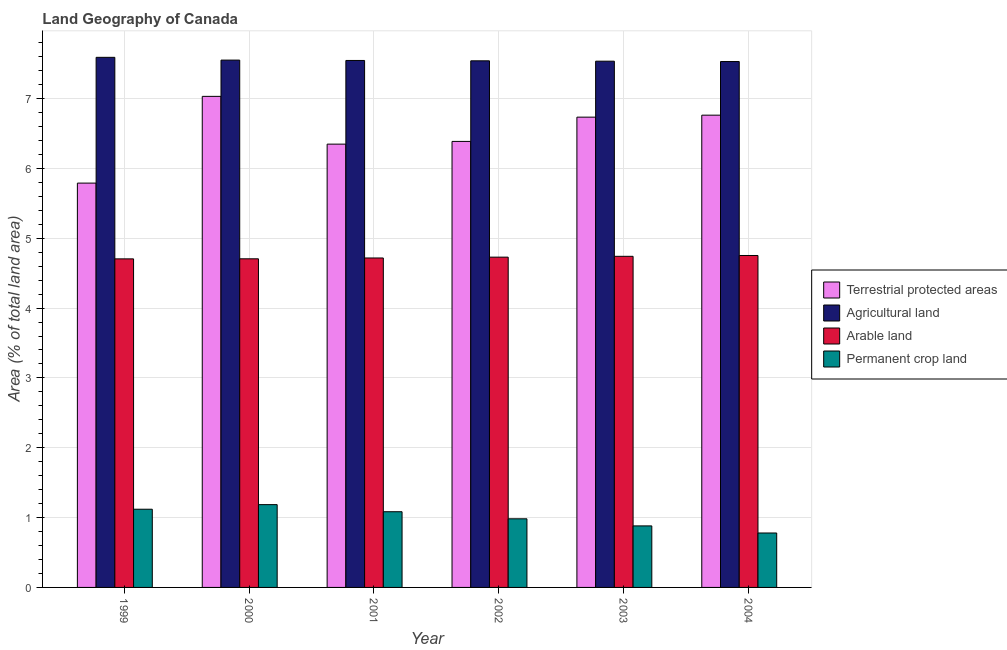How many groups of bars are there?
Your response must be concise. 6. Are the number of bars on each tick of the X-axis equal?
Your response must be concise. Yes. What is the percentage of area under agricultural land in 2000?
Keep it short and to the point. 7.55. Across all years, what is the maximum percentage of area under agricultural land?
Make the answer very short. 7.59. Across all years, what is the minimum percentage of area under permanent crop land?
Give a very brief answer. 0.78. In which year was the percentage of area under agricultural land maximum?
Your response must be concise. 1999. In which year was the percentage of area under arable land minimum?
Provide a short and direct response. 1999. What is the total percentage of area under agricultural land in the graph?
Give a very brief answer. 45.29. What is the difference between the percentage of area under permanent crop land in 1999 and that in 2004?
Your answer should be compact. 0.34. What is the difference between the percentage of area under permanent crop land in 2004 and the percentage of area under arable land in 2000?
Offer a terse response. -0.41. What is the average percentage of land under terrestrial protection per year?
Ensure brevity in your answer.  6.51. In the year 2001, what is the difference between the percentage of land under terrestrial protection and percentage of area under arable land?
Offer a terse response. 0. In how many years, is the percentage of land under terrestrial protection greater than 4.6 %?
Make the answer very short. 6. What is the ratio of the percentage of area under permanent crop land in 2002 to that in 2004?
Provide a short and direct response. 1.26. Is the percentage of area under permanent crop land in 2002 less than that in 2004?
Ensure brevity in your answer.  No. Is the difference between the percentage of land under terrestrial protection in 2003 and 2004 greater than the difference between the percentage of area under agricultural land in 2003 and 2004?
Your answer should be very brief. No. What is the difference between the highest and the second highest percentage of area under permanent crop land?
Keep it short and to the point. 0.07. What is the difference between the highest and the lowest percentage of land under terrestrial protection?
Provide a short and direct response. 1.24. In how many years, is the percentage of land under terrestrial protection greater than the average percentage of land under terrestrial protection taken over all years?
Ensure brevity in your answer.  3. Is the sum of the percentage of land under terrestrial protection in 2000 and 2002 greater than the maximum percentage of area under permanent crop land across all years?
Give a very brief answer. Yes. What does the 1st bar from the left in 2004 represents?
Your answer should be very brief. Terrestrial protected areas. What does the 3rd bar from the right in 2003 represents?
Give a very brief answer. Agricultural land. How many bars are there?
Ensure brevity in your answer.  24. Does the graph contain any zero values?
Offer a terse response. No. Does the graph contain grids?
Keep it short and to the point. Yes. Where does the legend appear in the graph?
Offer a very short reply. Center right. How are the legend labels stacked?
Provide a short and direct response. Vertical. What is the title of the graph?
Keep it short and to the point. Land Geography of Canada. Does "Luxembourg" appear as one of the legend labels in the graph?
Offer a very short reply. No. What is the label or title of the Y-axis?
Ensure brevity in your answer.  Area (% of total land area). What is the Area (% of total land area) of Terrestrial protected areas in 1999?
Offer a very short reply. 5.79. What is the Area (% of total land area) in Agricultural land in 1999?
Offer a very short reply. 7.59. What is the Area (% of total land area) of Arable land in 1999?
Offer a very short reply. 4.7. What is the Area (% of total land area) of Permanent crop land in 1999?
Your answer should be compact. 1.12. What is the Area (% of total land area) of Terrestrial protected areas in 2000?
Provide a succinct answer. 7.03. What is the Area (% of total land area) in Agricultural land in 2000?
Provide a succinct answer. 7.55. What is the Area (% of total land area) in Arable land in 2000?
Your answer should be compact. 4.71. What is the Area (% of total land area) in Permanent crop land in 2000?
Your answer should be very brief. 1.19. What is the Area (% of total land area) of Terrestrial protected areas in 2001?
Offer a very short reply. 6.35. What is the Area (% of total land area) in Agricultural land in 2001?
Provide a short and direct response. 7.55. What is the Area (% of total land area) of Arable land in 2001?
Your answer should be compact. 4.72. What is the Area (% of total land area) of Permanent crop land in 2001?
Provide a succinct answer. 1.08. What is the Area (% of total land area) of Terrestrial protected areas in 2002?
Provide a succinct answer. 6.39. What is the Area (% of total land area) in Agricultural land in 2002?
Your response must be concise. 7.54. What is the Area (% of total land area) in Arable land in 2002?
Your answer should be very brief. 4.73. What is the Area (% of total land area) of Permanent crop land in 2002?
Provide a short and direct response. 0.98. What is the Area (% of total land area) in Terrestrial protected areas in 2003?
Your answer should be compact. 6.73. What is the Area (% of total land area) in Agricultural land in 2003?
Offer a very short reply. 7.53. What is the Area (% of total land area) of Arable land in 2003?
Your response must be concise. 4.74. What is the Area (% of total land area) of Permanent crop land in 2003?
Keep it short and to the point. 0.88. What is the Area (% of total land area) of Terrestrial protected areas in 2004?
Your answer should be very brief. 6.76. What is the Area (% of total land area) in Agricultural land in 2004?
Provide a succinct answer. 7.53. What is the Area (% of total land area) in Arable land in 2004?
Provide a short and direct response. 4.75. What is the Area (% of total land area) of Permanent crop land in 2004?
Ensure brevity in your answer.  0.78. Across all years, what is the maximum Area (% of total land area) of Terrestrial protected areas?
Provide a succinct answer. 7.03. Across all years, what is the maximum Area (% of total land area) of Agricultural land?
Your answer should be very brief. 7.59. Across all years, what is the maximum Area (% of total land area) of Arable land?
Offer a terse response. 4.75. Across all years, what is the maximum Area (% of total land area) in Permanent crop land?
Offer a terse response. 1.19. Across all years, what is the minimum Area (% of total land area) in Terrestrial protected areas?
Your answer should be very brief. 5.79. Across all years, what is the minimum Area (% of total land area) in Agricultural land?
Offer a very short reply. 7.53. Across all years, what is the minimum Area (% of total land area) in Arable land?
Make the answer very short. 4.7. Across all years, what is the minimum Area (% of total land area) in Permanent crop land?
Ensure brevity in your answer.  0.78. What is the total Area (% of total land area) of Terrestrial protected areas in the graph?
Make the answer very short. 39.05. What is the total Area (% of total land area) of Agricultural land in the graph?
Provide a short and direct response. 45.29. What is the total Area (% of total land area) in Arable land in the graph?
Give a very brief answer. 28.35. What is the total Area (% of total land area) of Permanent crop land in the graph?
Keep it short and to the point. 6.03. What is the difference between the Area (% of total land area) of Terrestrial protected areas in 1999 and that in 2000?
Ensure brevity in your answer.  -1.24. What is the difference between the Area (% of total land area) in Agricultural land in 1999 and that in 2000?
Give a very brief answer. 0.04. What is the difference between the Area (% of total land area) of Arable land in 1999 and that in 2000?
Offer a terse response. -0. What is the difference between the Area (% of total land area) of Permanent crop land in 1999 and that in 2000?
Make the answer very short. -0.07. What is the difference between the Area (% of total land area) in Terrestrial protected areas in 1999 and that in 2001?
Your answer should be compact. -0.56. What is the difference between the Area (% of total land area) in Agricultural land in 1999 and that in 2001?
Offer a very short reply. 0.04. What is the difference between the Area (% of total land area) of Arable land in 1999 and that in 2001?
Make the answer very short. -0.01. What is the difference between the Area (% of total land area) of Permanent crop land in 1999 and that in 2001?
Your answer should be compact. 0.04. What is the difference between the Area (% of total land area) of Terrestrial protected areas in 1999 and that in 2002?
Make the answer very short. -0.6. What is the difference between the Area (% of total land area) of Arable land in 1999 and that in 2002?
Your response must be concise. -0.02. What is the difference between the Area (% of total land area) in Permanent crop land in 1999 and that in 2002?
Offer a terse response. 0.14. What is the difference between the Area (% of total land area) in Terrestrial protected areas in 1999 and that in 2003?
Ensure brevity in your answer.  -0.94. What is the difference between the Area (% of total land area) in Agricultural land in 1999 and that in 2003?
Offer a terse response. 0.06. What is the difference between the Area (% of total land area) of Arable land in 1999 and that in 2003?
Give a very brief answer. -0.04. What is the difference between the Area (% of total land area) of Permanent crop land in 1999 and that in 2003?
Provide a short and direct response. 0.24. What is the difference between the Area (% of total land area) in Terrestrial protected areas in 1999 and that in 2004?
Ensure brevity in your answer.  -0.97. What is the difference between the Area (% of total land area) of Agricultural land in 1999 and that in 2004?
Offer a terse response. 0.06. What is the difference between the Area (% of total land area) in Arable land in 1999 and that in 2004?
Offer a terse response. -0.05. What is the difference between the Area (% of total land area) in Permanent crop land in 1999 and that in 2004?
Give a very brief answer. 0.34. What is the difference between the Area (% of total land area) of Terrestrial protected areas in 2000 and that in 2001?
Give a very brief answer. 0.68. What is the difference between the Area (% of total land area) in Agricultural land in 2000 and that in 2001?
Offer a very short reply. 0.01. What is the difference between the Area (% of total land area) of Arable land in 2000 and that in 2001?
Keep it short and to the point. -0.01. What is the difference between the Area (% of total land area) in Permanent crop land in 2000 and that in 2001?
Provide a short and direct response. 0.1. What is the difference between the Area (% of total land area) in Terrestrial protected areas in 2000 and that in 2002?
Provide a short and direct response. 0.65. What is the difference between the Area (% of total land area) in Agricultural land in 2000 and that in 2002?
Make the answer very short. 0.01. What is the difference between the Area (% of total land area) of Arable land in 2000 and that in 2002?
Your answer should be very brief. -0.02. What is the difference between the Area (% of total land area) of Permanent crop land in 2000 and that in 2002?
Provide a short and direct response. 0.2. What is the difference between the Area (% of total land area) of Terrestrial protected areas in 2000 and that in 2003?
Keep it short and to the point. 0.3. What is the difference between the Area (% of total land area) of Agricultural land in 2000 and that in 2003?
Offer a terse response. 0.02. What is the difference between the Area (% of total land area) in Arable land in 2000 and that in 2003?
Offer a very short reply. -0.04. What is the difference between the Area (% of total land area) in Permanent crop land in 2000 and that in 2003?
Give a very brief answer. 0.3. What is the difference between the Area (% of total land area) in Terrestrial protected areas in 2000 and that in 2004?
Offer a terse response. 0.27. What is the difference between the Area (% of total land area) of Agricultural land in 2000 and that in 2004?
Keep it short and to the point. 0.02. What is the difference between the Area (% of total land area) in Arable land in 2000 and that in 2004?
Your answer should be compact. -0.05. What is the difference between the Area (% of total land area) of Permanent crop land in 2000 and that in 2004?
Make the answer very short. 0.41. What is the difference between the Area (% of total land area) of Terrestrial protected areas in 2001 and that in 2002?
Provide a short and direct response. -0.04. What is the difference between the Area (% of total land area) of Agricultural land in 2001 and that in 2002?
Give a very brief answer. 0.01. What is the difference between the Area (% of total land area) in Arable land in 2001 and that in 2002?
Your answer should be compact. -0.01. What is the difference between the Area (% of total land area) in Permanent crop land in 2001 and that in 2002?
Your response must be concise. 0.1. What is the difference between the Area (% of total land area) of Terrestrial protected areas in 2001 and that in 2003?
Ensure brevity in your answer.  -0.39. What is the difference between the Area (% of total land area) of Agricultural land in 2001 and that in 2003?
Give a very brief answer. 0.01. What is the difference between the Area (% of total land area) in Arable land in 2001 and that in 2003?
Make the answer very short. -0.02. What is the difference between the Area (% of total land area) in Permanent crop land in 2001 and that in 2003?
Offer a terse response. 0.2. What is the difference between the Area (% of total land area) in Terrestrial protected areas in 2001 and that in 2004?
Ensure brevity in your answer.  -0.41. What is the difference between the Area (% of total land area) of Agricultural land in 2001 and that in 2004?
Provide a succinct answer. 0.02. What is the difference between the Area (% of total land area) in Arable land in 2001 and that in 2004?
Give a very brief answer. -0.04. What is the difference between the Area (% of total land area) of Permanent crop land in 2001 and that in 2004?
Your response must be concise. 0.3. What is the difference between the Area (% of total land area) of Terrestrial protected areas in 2002 and that in 2003?
Ensure brevity in your answer.  -0.35. What is the difference between the Area (% of total land area) in Agricultural land in 2002 and that in 2003?
Make the answer very short. 0.01. What is the difference between the Area (% of total land area) of Arable land in 2002 and that in 2003?
Ensure brevity in your answer.  -0.01. What is the difference between the Area (% of total land area) of Permanent crop land in 2002 and that in 2003?
Offer a terse response. 0.1. What is the difference between the Area (% of total land area) in Terrestrial protected areas in 2002 and that in 2004?
Make the answer very short. -0.38. What is the difference between the Area (% of total land area) of Agricultural land in 2002 and that in 2004?
Ensure brevity in your answer.  0.01. What is the difference between the Area (% of total land area) of Arable land in 2002 and that in 2004?
Give a very brief answer. -0.02. What is the difference between the Area (% of total land area) of Permanent crop land in 2002 and that in 2004?
Provide a short and direct response. 0.2. What is the difference between the Area (% of total land area) in Terrestrial protected areas in 2003 and that in 2004?
Ensure brevity in your answer.  -0.03. What is the difference between the Area (% of total land area) of Agricultural land in 2003 and that in 2004?
Your answer should be very brief. 0.01. What is the difference between the Area (% of total land area) in Arable land in 2003 and that in 2004?
Provide a succinct answer. -0.01. What is the difference between the Area (% of total land area) of Permanent crop land in 2003 and that in 2004?
Your answer should be compact. 0.1. What is the difference between the Area (% of total land area) in Terrestrial protected areas in 1999 and the Area (% of total land area) in Agricultural land in 2000?
Provide a succinct answer. -1.76. What is the difference between the Area (% of total land area) in Terrestrial protected areas in 1999 and the Area (% of total land area) in Arable land in 2000?
Ensure brevity in your answer.  1.08. What is the difference between the Area (% of total land area) in Terrestrial protected areas in 1999 and the Area (% of total land area) in Permanent crop land in 2000?
Provide a succinct answer. 4.6. What is the difference between the Area (% of total land area) of Agricultural land in 1999 and the Area (% of total land area) of Arable land in 2000?
Offer a terse response. 2.88. What is the difference between the Area (% of total land area) of Agricultural land in 1999 and the Area (% of total land area) of Permanent crop land in 2000?
Your response must be concise. 6.4. What is the difference between the Area (% of total land area) of Arable land in 1999 and the Area (% of total land area) of Permanent crop land in 2000?
Give a very brief answer. 3.52. What is the difference between the Area (% of total land area) of Terrestrial protected areas in 1999 and the Area (% of total land area) of Agricultural land in 2001?
Keep it short and to the point. -1.76. What is the difference between the Area (% of total land area) in Terrestrial protected areas in 1999 and the Area (% of total land area) in Arable land in 2001?
Offer a very short reply. 1.07. What is the difference between the Area (% of total land area) in Terrestrial protected areas in 1999 and the Area (% of total land area) in Permanent crop land in 2001?
Ensure brevity in your answer.  4.71. What is the difference between the Area (% of total land area) of Agricultural land in 1999 and the Area (% of total land area) of Arable land in 2001?
Your answer should be very brief. 2.87. What is the difference between the Area (% of total land area) of Agricultural land in 1999 and the Area (% of total land area) of Permanent crop land in 2001?
Keep it short and to the point. 6.51. What is the difference between the Area (% of total land area) of Arable land in 1999 and the Area (% of total land area) of Permanent crop land in 2001?
Your answer should be very brief. 3.62. What is the difference between the Area (% of total land area) in Terrestrial protected areas in 1999 and the Area (% of total land area) in Agricultural land in 2002?
Provide a short and direct response. -1.75. What is the difference between the Area (% of total land area) of Terrestrial protected areas in 1999 and the Area (% of total land area) of Arable land in 2002?
Your answer should be compact. 1.06. What is the difference between the Area (% of total land area) of Terrestrial protected areas in 1999 and the Area (% of total land area) of Permanent crop land in 2002?
Provide a succinct answer. 4.81. What is the difference between the Area (% of total land area) of Agricultural land in 1999 and the Area (% of total land area) of Arable land in 2002?
Your answer should be very brief. 2.86. What is the difference between the Area (% of total land area) in Agricultural land in 1999 and the Area (% of total land area) in Permanent crop land in 2002?
Your answer should be very brief. 6.61. What is the difference between the Area (% of total land area) in Arable land in 1999 and the Area (% of total land area) in Permanent crop land in 2002?
Provide a succinct answer. 3.72. What is the difference between the Area (% of total land area) in Terrestrial protected areas in 1999 and the Area (% of total land area) in Agricultural land in 2003?
Make the answer very short. -1.75. What is the difference between the Area (% of total land area) in Terrestrial protected areas in 1999 and the Area (% of total land area) in Arable land in 2003?
Provide a short and direct response. 1.05. What is the difference between the Area (% of total land area) of Terrestrial protected areas in 1999 and the Area (% of total land area) of Permanent crop land in 2003?
Offer a very short reply. 4.91. What is the difference between the Area (% of total land area) in Agricultural land in 1999 and the Area (% of total land area) in Arable land in 2003?
Offer a terse response. 2.85. What is the difference between the Area (% of total land area) of Agricultural land in 1999 and the Area (% of total land area) of Permanent crop land in 2003?
Your answer should be compact. 6.71. What is the difference between the Area (% of total land area) in Arable land in 1999 and the Area (% of total land area) in Permanent crop land in 2003?
Your answer should be compact. 3.82. What is the difference between the Area (% of total land area) in Terrestrial protected areas in 1999 and the Area (% of total land area) in Agricultural land in 2004?
Provide a short and direct response. -1.74. What is the difference between the Area (% of total land area) of Terrestrial protected areas in 1999 and the Area (% of total land area) of Arable land in 2004?
Ensure brevity in your answer.  1.04. What is the difference between the Area (% of total land area) of Terrestrial protected areas in 1999 and the Area (% of total land area) of Permanent crop land in 2004?
Give a very brief answer. 5.01. What is the difference between the Area (% of total land area) of Agricultural land in 1999 and the Area (% of total land area) of Arable land in 2004?
Give a very brief answer. 2.84. What is the difference between the Area (% of total land area) of Agricultural land in 1999 and the Area (% of total land area) of Permanent crop land in 2004?
Give a very brief answer. 6.81. What is the difference between the Area (% of total land area) in Arable land in 1999 and the Area (% of total land area) in Permanent crop land in 2004?
Your answer should be compact. 3.92. What is the difference between the Area (% of total land area) of Terrestrial protected areas in 2000 and the Area (% of total land area) of Agricultural land in 2001?
Provide a succinct answer. -0.51. What is the difference between the Area (% of total land area) in Terrestrial protected areas in 2000 and the Area (% of total land area) in Arable land in 2001?
Your answer should be compact. 2.31. What is the difference between the Area (% of total land area) of Terrestrial protected areas in 2000 and the Area (% of total land area) of Permanent crop land in 2001?
Give a very brief answer. 5.95. What is the difference between the Area (% of total land area) of Agricultural land in 2000 and the Area (% of total land area) of Arable land in 2001?
Make the answer very short. 2.83. What is the difference between the Area (% of total land area) of Agricultural land in 2000 and the Area (% of total land area) of Permanent crop land in 2001?
Ensure brevity in your answer.  6.47. What is the difference between the Area (% of total land area) in Arable land in 2000 and the Area (% of total land area) in Permanent crop land in 2001?
Provide a succinct answer. 3.62. What is the difference between the Area (% of total land area) in Terrestrial protected areas in 2000 and the Area (% of total land area) in Agricultural land in 2002?
Ensure brevity in your answer.  -0.51. What is the difference between the Area (% of total land area) in Terrestrial protected areas in 2000 and the Area (% of total land area) in Arable land in 2002?
Ensure brevity in your answer.  2.3. What is the difference between the Area (% of total land area) in Terrestrial protected areas in 2000 and the Area (% of total land area) in Permanent crop land in 2002?
Your answer should be compact. 6.05. What is the difference between the Area (% of total land area) in Agricultural land in 2000 and the Area (% of total land area) in Arable land in 2002?
Offer a very short reply. 2.82. What is the difference between the Area (% of total land area) in Agricultural land in 2000 and the Area (% of total land area) in Permanent crop land in 2002?
Ensure brevity in your answer.  6.57. What is the difference between the Area (% of total land area) of Arable land in 2000 and the Area (% of total land area) of Permanent crop land in 2002?
Offer a very short reply. 3.72. What is the difference between the Area (% of total land area) in Terrestrial protected areas in 2000 and the Area (% of total land area) in Agricultural land in 2003?
Ensure brevity in your answer.  -0.5. What is the difference between the Area (% of total land area) of Terrestrial protected areas in 2000 and the Area (% of total land area) of Arable land in 2003?
Provide a short and direct response. 2.29. What is the difference between the Area (% of total land area) in Terrestrial protected areas in 2000 and the Area (% of total land area) in Permanent crop land in 2003?
Your answer should be very brief. 6.15. What is the difference between the Area (% of total land area) of Agricultural land in 2000 and the Area (% of total land area) of Arable land in 2003?
Make the answer very short. 2.81. What is the difference between the Area (% of total land area) in Agricultural land in 2000 and the Area (% of total land area) in Permanent crop land in 2003?
Offer a very short reply. 6.67. What is the difference between the Area (% of total land area) of Arable land in 2000 and the Area (% of total land area) of Permanent crop land in 2003?
Provide a succinct answer. 3.82. What is the difference between the Area (% of total land area) in Terrestrial protected areas in 2000 and the Area (% of total land area) in Agricultural land in 2004?
Keep it short and to the point. -0.5. What is the difference between the Area (% of total land area) of Terrestrial protected areas in 2000 and the Area (% of total land area) of Arable land in 2004?
Keep it short and to the point. 2.28. What is the difference between the Area (% of total land area) of Terrestrial protected areas in 2000 and the Area (% of total land area) of Permanent crop land in 2004?
Your response must be concise. 6.25. What is the difference between the Area (% of total land area) of Agricultural land in 2000 and the Area (% of total land area) of Arable land in 2004?
Offer a terse response. 2.8. What is the difference between the Area (% of total land area) of Agricultural land in 2000 and the Area (% of total land area) of Permanent crop land in 2004?
Make the answer very short. 6.77. What is the difference between the Area (% of total land area) in Arable land in 2000 and the Area (% of total land area) in Permanent crop land in 2004?
Ensure brevity in your answer.  3.93. What is the difference between the Area (% of total land area) of Terrestrial protected areas in 2001 and the Area (% of total land area) of Agricultural land in 2002?
Make the answer very short. -1.19. What is the difference between the Area (% of total land area) of Terrestrial protected areas in 2001 and the Area (% of total land area) of Arable land in 2002?
Your answer should be compact. 1.62. What is the difference between the Area (% of total land area) in Terrestrial protected areas in 2001 and the Area (% of total land area) in Permanent crop land in 2002?
Your answer should be very brief. 5.36. What is the difference between the Area (% of total land area) of Agricultural land in 2001 and the Area (% of total land area) of Arable land in 2002?
Provide a short and direct response. 2.82. What is the difference between the Area (% of total land area) in Agricultural land in 2001 and the Area (% of total land area) in Permanent crop land in 2002?
Your answer should be very brief. 6.56. What is the difference between the Area (% of total land area) of Arable land in 2001 and the Area (% of total land area) of Permanent crop land in 2002?
Keep it short and to the point. 3.73. What is the difference between the Area (% of total land area) in Terrestrial protected areas in 2001 and the Area (% of total land area) in Agricultural land in 2003?
Your answer should be compact. -1.19. What is the difference between the Area (% of total land area) in Terrestrial protected areas in 2001 and the Area (% of total land area) in Arable land in 2003?
Your answer should be compact. 1.61. What is the difference between the Area (% of total land area) in Terrestrial protected areas in 2001 and the Area (% of total land area) in Permanent crop land in 2003?
Your answer should be compact. 5.47. What is the difference between the Area (% of total land area) in Agricultural land in 2001 and the Area (% of total land area) in Arable land in 2003?
Your answer should be very brief. 2.8. What is the difference between the Area (% of total land area) of Agricultural land in 2001 and the Area (% of total land area) of Permanent crop land in 2003?
Keep it short and to the point. 6.66. What is the difference between the Area (% of total land area) of Arable land in 2001 and the Area (% of total land area) of Permanent crop land in 2003?
Offer a very short reply. 3.84. What is the difference between the Area (% of total land area) in Terrestrial protected areas in 2001 and the Area (% of total land area) in Agricultural land in 2004?
Provide a short and direct response. -1.18. What is the difference between the Area (% of total land area) in Terrestrial protected areas in 2001 and the Area (% of total land area) in Arable land in 2004?
Keep it short and to the point. 1.59. What is the difference between the Area (% of total land area) of Terrestrial protected areas in 2001 and the Area (% of total land area) of Permanent crop land in 2004?
Give a very brief answer. 5.57. What is the difference between the Area (% of total land area) of Agricultural land in 2001 and the Area (% of total land area) of Arable land in 2004?
Offer a very short reply. 2.79. What is the difference between the Area (% of total land area) of Agricultural land in 2001 and the Area (% of total land area) of Permanent crop land in 2004?
Give a very brief answer. 6.77. What is the difference between the Area (% of total land area) in Arable land in 2001 and the Area (% of total land area) in Permanent crop land in 2004?
Your answer should be very brief. 3.94. What is the difference between the Area (% of total land area) of Terrestrial protected areas in 2002 and the Area (% of total land area) of Agricultural land in 2003?
Your answer should be compact. -1.15. What is the difference between the Area (% of total land area) in Terrestrial protected areas in 2002 and the Area (% of total land area) in Arable land in 2003?
Ensure brevity in your answer.  1.65. What is the difference between the Area (% of total land area) in Terrestrial protected areas in 2002 and the Area (% of total land area) in Permanent crop land in 2003?
Ensure brevity in your answer.  5.51. What is the difference between the Area (% of total land area) in Agricultural land in 2002 and the Area (% of total land area) in Arable land in 2003?
Keep it short and to the point. 2.8. What is the difference between the Area (% of total land area) of Agricultural land in 2002 and the Area (% of total land area) of Permanent crop land in 2003?
Your response must be concise. 6.66. What is the difference between the Area (% of total land area) in Arable land in 2002 and the Area (% of total land area) in Permanent crop land in 2003?
Ensure brevity in your answer.  3.85. What is the difference between the Area (% of total land area) in Terrestrial protected areas in 2002 and the Area (% of total land area) in Agricultural land in 2004?
Your answer should be very brief. -1.14. What is the difference between the Area (% of total land area) of Terrestrial protected areas in 2002 and the Area (% of total land area) of Arable land in 2004?
Make the answer very short. 1.63. What is the difference between the Area (% of total land area) of Terrestrial protected areas in 2002 and the Area (% of total land area) of Permanent crop land in 2004?
Your answer should be very brief. 5.61. What is the difference between the Area (% of total land area) of Agricultural land in 2002 and the Area (% of total land area) of Arable land in 2004?
Make the answer very short. 2.79. What is the difference between the Area (% of total land area) of Agricultural land in 2002 and the Area (% of total land area) of Permanent crop land in 2004?
Your response must be concise. 6.76. What is the difference between the Area (% of total land area) in Arable land in 2002 and the Area (% of total land area) in Permanent crop land in 2004?
Your answer should be compact. 3.95. What is the difference between the Area (% of total land area) of Terrestrial protected areas in 2003 and the Area (% of total land area) of Agricultural land in 2004?
Provide a succinct answer. -0.8. What is the difference between the Area (% of total land area) of Terrestrial protected areas in 2003 and the Area (% of total land area) of Arable land in 2004?
Offer a very short reply. 1.98. What is the difference between the Area (% of total land area) of Terrestrial protected areas in 2003 and the Area (% of total land area) of Permanent crop land in 2004?
Ensure brevity in your answer.  5.95. What is the difference between the Area (% of total land area) of Agricultural land in 2003 and the Area (% of total land area) of Arable land in 2004?
Your answer should be compact. 2.78. What is the difference between the Area (% of total land area) of Agricultural land in 2003 and the Area (% of total land area) of Permanent crop land in 2004?
Ensure brevity in your answer.  6.76. What is the difference between the Area (% of total land area) in Arable land in 2003 and the Area (% of total land area) in Permanent crop land in 2004?
Ensure brevity in your answer.  3.96. What is the average Area (% of total land area) in Terrestrial protected areas per year?
Your answer should be compact. 6.51. What is the average Area (% of total land area) of Agricultural land per year?
Give a very brief answer. 7.55. What is the average Area (% of total land area) of Arable land per year?
Provide a succinct answer. 4.72. What is the average Area (% of total land area) of Permanent crop land per year?
Provide a short and direct response. 1.01. In the year 1999, what is the difference between the Area (% of total land area) of Terrestrial protected areas and Area (% of total land area) of Agricultural land?
Keep it short and to the point. -1.8. In the year 1999, what is the difference between the Area (% of total land area) in Terrestrial protected areas and Area (% of total land area) in Arable land?
Your answer should be compact. 1.08. In the year 1999, what is the difference between the Area (% of total land area) in Terrestrial protected areas and Area (% of total land area) in Permanent crop land?
Provide a short and direct response. 4.67. In the year 1999, what is the difference between the Area (% of total land area) in Agricultural land and Area (% of total land area) in Arable land?
Provide a short and direct response. 2.89. In the year 1999, what is the difference between the Area (% of total land area) in Agricultural land and Area (% of total land area) in Permanent crop land?
Make the answer very short. 6.47. In the year 1999, what is the difference between the Area (% of total land area) in Arable land and Area (% of total land area) in Permanent crop land?
Provide a short and direct response. 3.58. In the year 2000, what is the difference between the Area (% of total land area) of Terrestrial protected areas and Area (% of total land area) of Agricultural land?
Give a very brief answer. -0.52. In the year 2000, what is the difference between the Area (% of total land area) of Terrestrial protected areas and Area (% of total land area) of Arable land?
Give a very brief answer. 2.33. In the year 2000, what is the difference between the Area (% of total land area) in Terrestrial protected areas and Area (% of total land area) in Permanent crop land?
Provide a short and direct response. 5.85. In the year 2000, what is the difference between the Area (% of total land area) of Agricultural land and Area (% of total land area) of Arable land?
Ensure brevity in your answer.  2.85. In the year 2000, what is the difference between the Area (% of total land area) in Agricultural land and Area (% of total land area) in Permanent crop land?
Give a very brief answer. 6.37. In the year 2000, what is the difference between the Area (% of total land area) of Arable land and Area (% of total land area) of Permanent crop land?
Ensure brevity in your answer.  3.52. In the year 2001, what is the difference between the Area (% of total land area) of Terrestrial protected areas and Area (% of total land area) of Agricultural land?
Keep it short and to the point. -1.2. In the year 2001, what is the difference between the Area (% of total land area) of Terrestrial protected areas and Area (% of total land area) of Arable land?
Keep it short and to the point. 1.63. In the year 2001, what is the difference between the Area (% of total land area) in Terrestrial protected areas and Area (% of total land area) in Permanent crop land?
Your answer should be very brief. 5.26. In the year 2001, what is the difference between the Area (% of total land area) in Agricultural land and Area (% of total land area) in Arable land?
Keep it short and to the point. 2.83. In the year 2001, what is the difference between the Area (% of total land area) of Agricultural land and Area (% of total land area) of Permanent crop land?
Ensure brevity in your answer.  6.46. In the year 2001, what is the difference between the Area (% of total land area) of Arable land and Area (% of total land area) of Permanent crop land?
Your answer should be very brief. 3.63. In the year 2002, what is the difference between the Area (% of total land area) of Terrestrial protected areas and Area (% of total land area) of Agricultural land?
Provide a short and direct response. -1.15. In the year 2002, what is the difference between the Area (% of total land area) of Terrestrial protected areas and Area (% of total land area) of Arable land?
Provide a short and direct response. 1.66. In the year 2002, what is the difference between the Area (% of total land area) in Terrestrial protected areas and Area (% of total land area) in Permanent crop land?
Provide a succinct answer. 5.4. In the year 2002, what is the difference between the Area (% of total land area) of Agricultural land and Area (% of total land area) of Arable land?
Provide a succinct answer. 2.81. In the year 2002, what is the difference between the Area (% of total land area) of Agricultural land and Area (% of total land area) of Permanent crop land?
Keep it short and to the point. 6.56. In the year 2002, what is the difference between the Area (% of total land area) of Arable land and Area (% of total land area) of Permanent crop land?
Provide a short and direct response. 3.75. In the year 2003, what is the difference between the Area (% of total land area) in Terrestrial protected areas and Area (% of total land area) in Agricultural land?
Offer a very short reply. -0.8. In the year 2003, what is the difference between the Area (% of total land area) of Terrestrial protected areas and Area (% of total land area) of Arable land?
Offer a terse response. 1.99. In the year 2003, what is the difference between the Area (% of total land area) of Terrestrial protected areas and Area (% of total land area) of Permanent crop land?
Ensure brevity in your answer.  5.85. In the year 2003, what is the difference between the Area (% of total land area) of Agricultural land and Area (% of total land area) of Arable land?
Ensure brevity in your answer.  2.79. In the year 2003, what is the difference between the Area (% of total land area) in Agricultural land and Area (% of total land area) in Permanent crop land?
Provide a short and direct response. 6.65. In the year 2003, what is the difference between the Area (% of total land area) of Arable land and Area (% of total land area) of Permanent crop land?
Provide a short and direct response. 3.86. In the year 2004, what is the difference between the Area (% of total land area) in Terrestrial protected areas and Area (% of total land area) in Agricultural land?
Provide a succinct answer. -0.77. In the year 2004, what is the difference between the Area (% of total land area) in Terrestrial protected areas and Area (% of total land area) in Arable land?
Provide a succinct answer. 2.01. In the year 2004, what is the difference between the Area (% of total land area) of Terrestrial protected areas and Area (% of total land area) of Permanent crop land?
Your response must be concise. 5.98. In the year 2004, what is the difference between the Area (% of total land area) in Agricultural land and Area (% of total land area) in Arable land?
Your answer should be very brief. 2.78. In the year 2004, what is the difference between the Area (% of total land area) of Agricultural land and Area (% of total land area) of Permanent crop land?
Offer a very short reply. 6.75. In the year 2004, what is the difference between the Area (% of total land area) of Arable land and Area (% of total land area) of Permanent crop land?
Offer a terse response. 3.97. What is the ratio of the Area (% of total land area) in Terrestrial protected areas in 1999 to that in 2000?
Provide a short and direct response. 0.82. What is the ratio of the Area (% of total land area) of Agricultural land in 1999 to that in 2000?
Make the answer very short. 1.01. What is the ratio of the Area (% of total land area) of Terrestrial protected areas in 1999 to that in 2001?
Give a very brief answer. 0.91. What is the ratio of the Area (% of total land area) of Agricultural land in 1999 to that in 2001?
Keep it short and to the point. 1.01. What is the ratio of the Area (% of total land area) of Arable land in 1999 to that in 2001?
Provide a short and direct response. 1. What is the ratio of the Area (% of total land area) of Permanent crop land in 1999 to that in 2001?
Your response must be concise. 1.03. What is the ratio of the Area (% of total land area) of Terrestrial protected areas in 1999 to that in 2002?
Your answer should be compact. 0.91. What is the ratio of the Area (% of total land area) in Agricultural land in 1999 to that in 2002?
Give a very brief answer. 1.01. What is the ratio of the Area (% of total land area) in Arable land in 1999 to that in 2002?
Keep it short and to the point. 0.99. What is the ratio of the Area (% of total land area) in Permanent crop land in 1999 to that in 2002?
Provide a short and direct response. 1.14. What is the ratio of the Area (% of total land area) of Terrestrial protected areas in 1999 to that in 2003?
Make the answer very short. 0.86. What is the ratio of the Area (% of total land area) in Agricultural land in 1999 to that in 2003?
Make the answer very short. 1.01. What is the ratio of the Area (% of total land area) in Arable land in 1999 to that in 2003?
Offer a very short reply. 0.99. What is the ratio of the Area (% of total land area) in Permanent crop land in 1999 to that in 2003?
Ensure brevity in your answer.  1.27. What is the ratio of the Area (% of total land area) of Terrestrial protected areas in 1999 to that in 2004?
Make the answer very short. 0.86. What is the ratio of the Area (% of total land area) of Permanent crop land in 1999 to that in 2004?
Provide a short and direct response. 1.44. What is the ratio of the Area (% of total land area) of Terrestrial protected areas in 2000 to that in 2001?
Provide a short and direct response. 1.11. What is the ratio of the Area (% of total land area) of Arable land in 2000 to that in 2001?
Your answer should be compact. 1. What is the ratio of the Area (% of total land area) in Permanent crop land in 2000 to that in 2001?
Provide a succinct answer. 1.09. What is the ratio of the Area (% of total land area) of Terrestrial protected areas in 2000 to that in 2002?
Offer a very short reply. 1.1. What is the ratio of the Area (% of total land area) in Permanent crop land in 2000 to that in 2002?
Provide a short and direct response. 1.21. What is the ratio of the Area (% of total land area) in Terrestrial protected areas in 2000 to that in 2003?
Keep it short and to the point. 1.04. What is the ratio of the Area (% of total land area) of Agricultural land in 2000 to that in 2003?
Give a very brief answer. 1. What is the ratio of the Area (% of total land area) of Arable land in 2000 to that in 2003?
Offer a terse response. 0.99. What is the ratio of the Area (% of total land area) in Permanent crop land in 2000 to that in 2003?
Your answer should be compact. 1.35. What is the ratio of the Area (% of total land area) in Terrestrial protected areas in 2000 to that in 2004?
Your answer should be very brief. 1.04. What is the ratio of the Area (% of total land area) of Agricultural land in 2000 to that in 2004?
Ensure brevity in your answer.  1. What is the ratio of the Area (% of total land area) in Permanent crop land in 2000 to that in 2004?
Ensure brevity in your answer.  1.52. What is the ratio of the Area (% of total land area) in Terrestrial protected areas in 2001 to that in 2002?
Your answer should be very brief. 0.99. What is the ratio of the Area (% of total land area) in Permanent crop land in 2001 to that in 2002?
Keep it short and to the point. 1.1. What is the ratio of the Area (% of total land area) of Terrestrial protected areas in 2001 to that in 2003?
Keep it short and to the point. 0.94. What is the ratio of the Area (% of total land area) in Arable land in 2001 to that in 2003?
Provide a succinct answer. 0.99. What is the ratio of the Area (% of total land area) in Permanent crop land in 2001 to that in 2003?
Your answer should be compact. 1.23. What is the ratio of the Area (% of total land area) in Terrestrial protected areas in 2001 to that in 2004?
Keep it short and to the point. 0.94. What is the ratio of the Area (% of total land area) of Agricultural land in 2001 to that in 2004?
Offer a terse response. 1. What is the ratio of the Area (% of total land area) in Arable land in 2001 to that in 2004?
Offer a terse response. 0.99. What is the ratio of the Area (% of total land area) in Permanent crop land in 2001 to that in 2004?
Your response must be concise. 1.39. What is the ratio of the Area (% of total land area) of Terrestrial protected areas in 2002 to that in 2003?
Your answer should be compact. 0.95. What is the ratio of the Area (% of total land area) in Agricultural land in 2002 to that in 2003?
Ensure brevity in your answer.  1. What is the ratio of the Area (% of total land area) in Arable land in 2002 to that in 2003?
Provide a succinct answer. 1. What is the ratio of the Area (% of total land area) in Permanent crop land in 2002 to that in 2003?
Ensure brevity in your answer.  1.12. What is the ratio of the Area (% of total land area) in Agricultural land in 2002 to that in 2004?
Provide a succinct answer. 1. What is the ratio of the Area (% of total land area) of Arable land in 2002 to that in 2004?
Provide a succinct answer. 0.99. What is the ratio of the Area (% of total land area) in Permanent crop land in 2002 to that in 2004?
Provide a succinct answer. 1.26. What is the ratio of the Area (% of total land area) in Terrestrial protected areas in 2003 to that in 2004?
Offer a terse response. 1. What is the ratio of the Area (% of total land area) of Agricultural land in 2003 to that in 2004?
Offer a terse response. 1. What is the ratio of the Area (% of total land area) of Arable land in 2003 to that in 2004?
Your response must be concise. 1. What is the ratio of the Area (% of total land area) in Permanent crop land in 2003 to that in 2004?
Offer a very short reply. 1.13. What is the difference between the highest and the second highest Area (% of total land area) in Terrestrial protected areas?
Your response must be concise. 0.27. What is the difference between the highest and the second highest Area (% of total land area) of Agricultural land?
Make the answer very short. 0.04. What is the difference between the highest and the second highest Area (% of total land area) in Arable land?
Give a very brief answer. 0.01. What is the difference between the highest and the second highest Area (% of total land area) of Permanent crop land?
Offer a very short reply. 0.07. What is the difference between the highest and the lowest Area (% of total land area) of Terrestrial protected areas?
Your answer should be very brief. 1.24. What is the difference between the highest and the lowest Area (% of total land area) in Agricultural land?
Make the answer very short. 0.06. What is the difference between the highest and the lowest Area (% of total land area) in Arable land?
Make the answer very short. 0.05. What is the difference between the highest and the lowest Area (% of total land area) in Permanent crop land?
Provide a short and direct response. 0.41. 